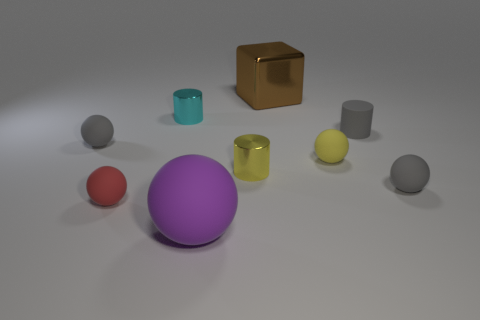Subtract all purple balls. How many balls are left? 4 Subtract all purple spheres. How many spheres are left? 4 Subtract all yellow cylinders. Subtract all green blocks. How many cylinders are left? 2 Add 1 tiny yellow spheres. How many objects exist? 10 Subtract all spheres. How many objects are left? 4 Subtract all large brown things. Subtract all tiny cyan shiny cylinders. How many objects are left? 7 Add 1 big matte objects. How many big matte objects are left? 2 Add 4 shiny things. How many shiny things exist? 7 Subtract 1 cyan cylinders. How many objects are left? 8 